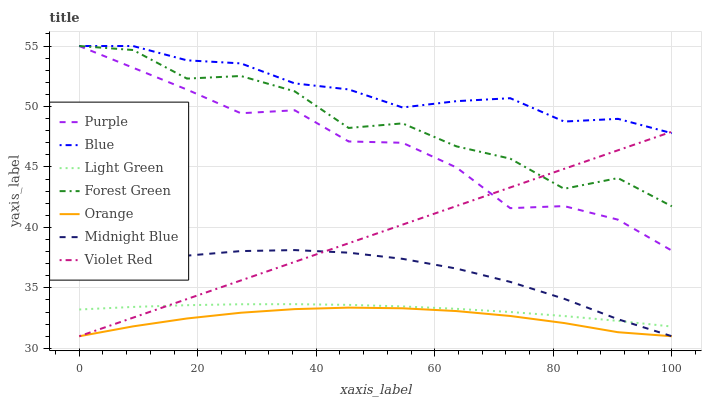Does Orange have the minimum area under the curve?
Answer yes or no. Yes. Does Blue have the maximum area under the curve?
Answer yes or no. Yes. Does Violet Red have the minimum area under the curve?
Answer yes or no. No. Does Violet Red have the maximum area under the curve?
Answer yes or no. No. Is Violet Red the smoothest?
Answer yes or no. Yes. Is Forest Green the roughest?
Answer yes or no. Yes. Is Midnight Blue the smoothest?
Answer yes or no. No. Is Midnight Blue the roughest?
Answer yes or no. No. Does Violet Red have the lowest value?
Answer yes or no. Yes. Does Purple have the lowest value?
Answer yes or no. No. Does Forest Green have the highest value?
Answer yes or no. Yes. Does Violet Red have the highest value?
Answer yes or no. No. Is Light Green less than Purple?
Answer yes or no. Yes. Is Forest Green greater than Midnight Blue?
Answer yes or no. Yes. Does Midnight Blue intersect Orange?
Answer yes or no. Yes. Is Midnight Blue less than Orange?
Answer yes or no. No. Is Midnight Blue greater than Orange?
Answer yes or no. No. Does Light Green intersect Purple?
Answer yes or no. No. 